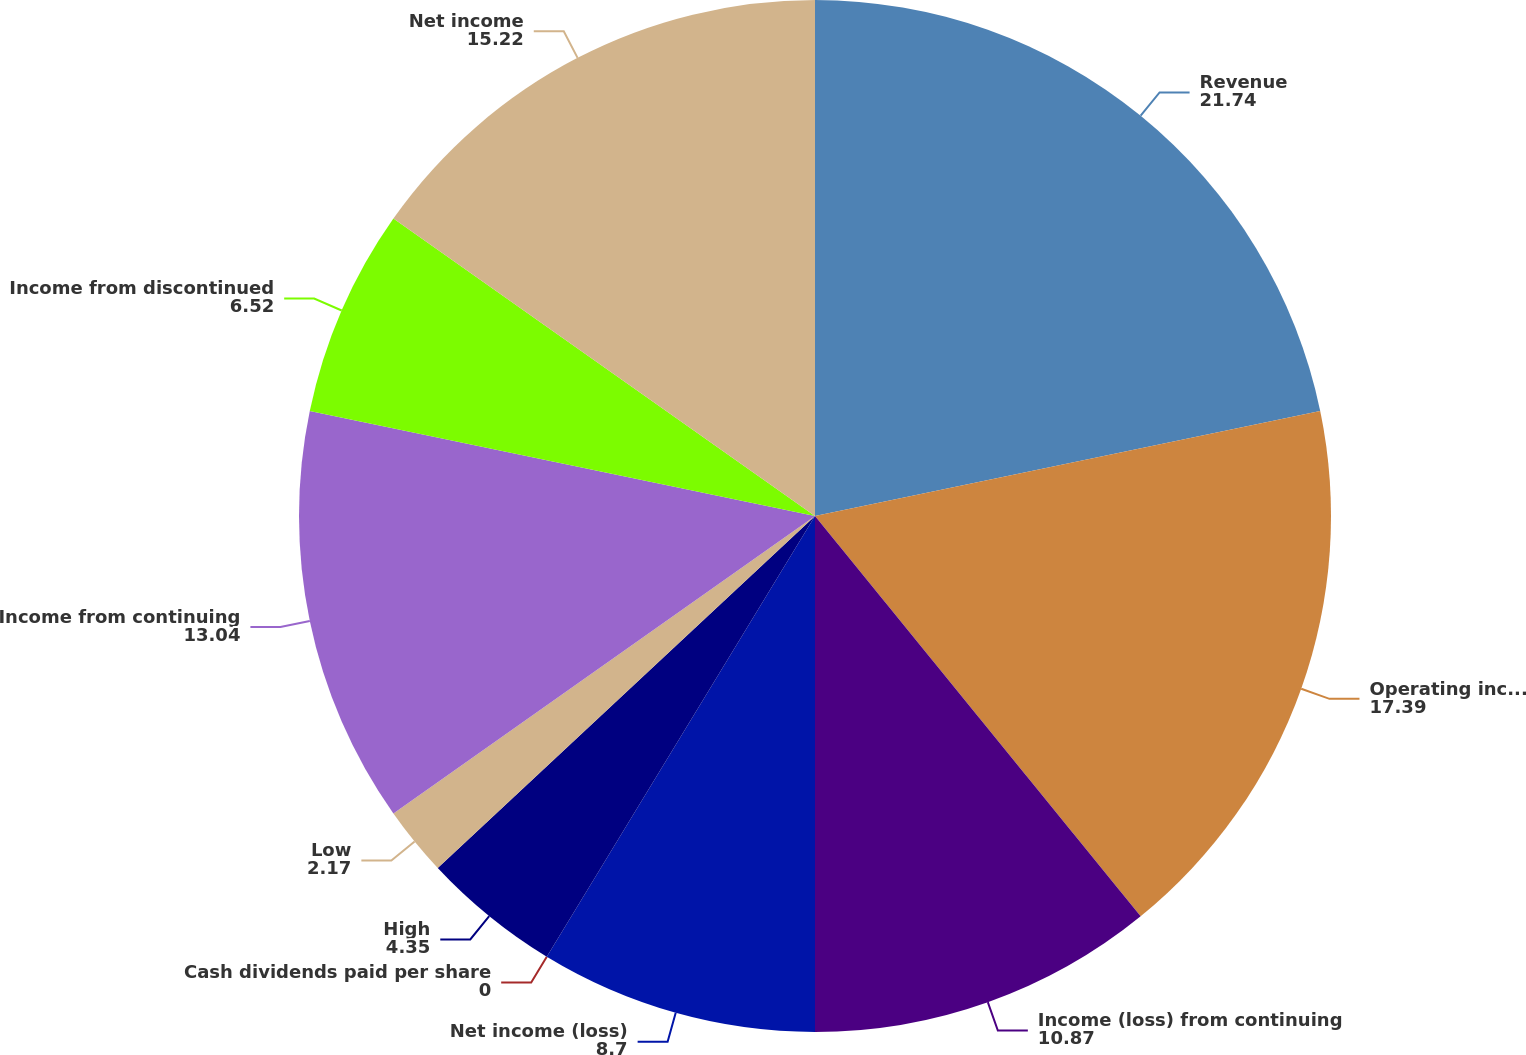Convert chart. <chart><loc_0><loc_0><loc_500><loc_500><pie_chart><fcel>Revenue<fcel>Operating income<fcel>Income (loss) from continuing<fcel>Net income (loss)<fcel>Cash dividends paid per share<fcel>High<fcel>Low<fcel>Income from continuing<fcel>Income from discontinued<fcel>Net income<nl><fcel>21.74%<fcel>17.39%<fcel>10.87%<fcel>8.7%<fcel>0.0%<fcel>4.35%<fcel>2.17%<fcel>13.04%<fcel>6.52%<fcel>15.22%<nl></chart> 